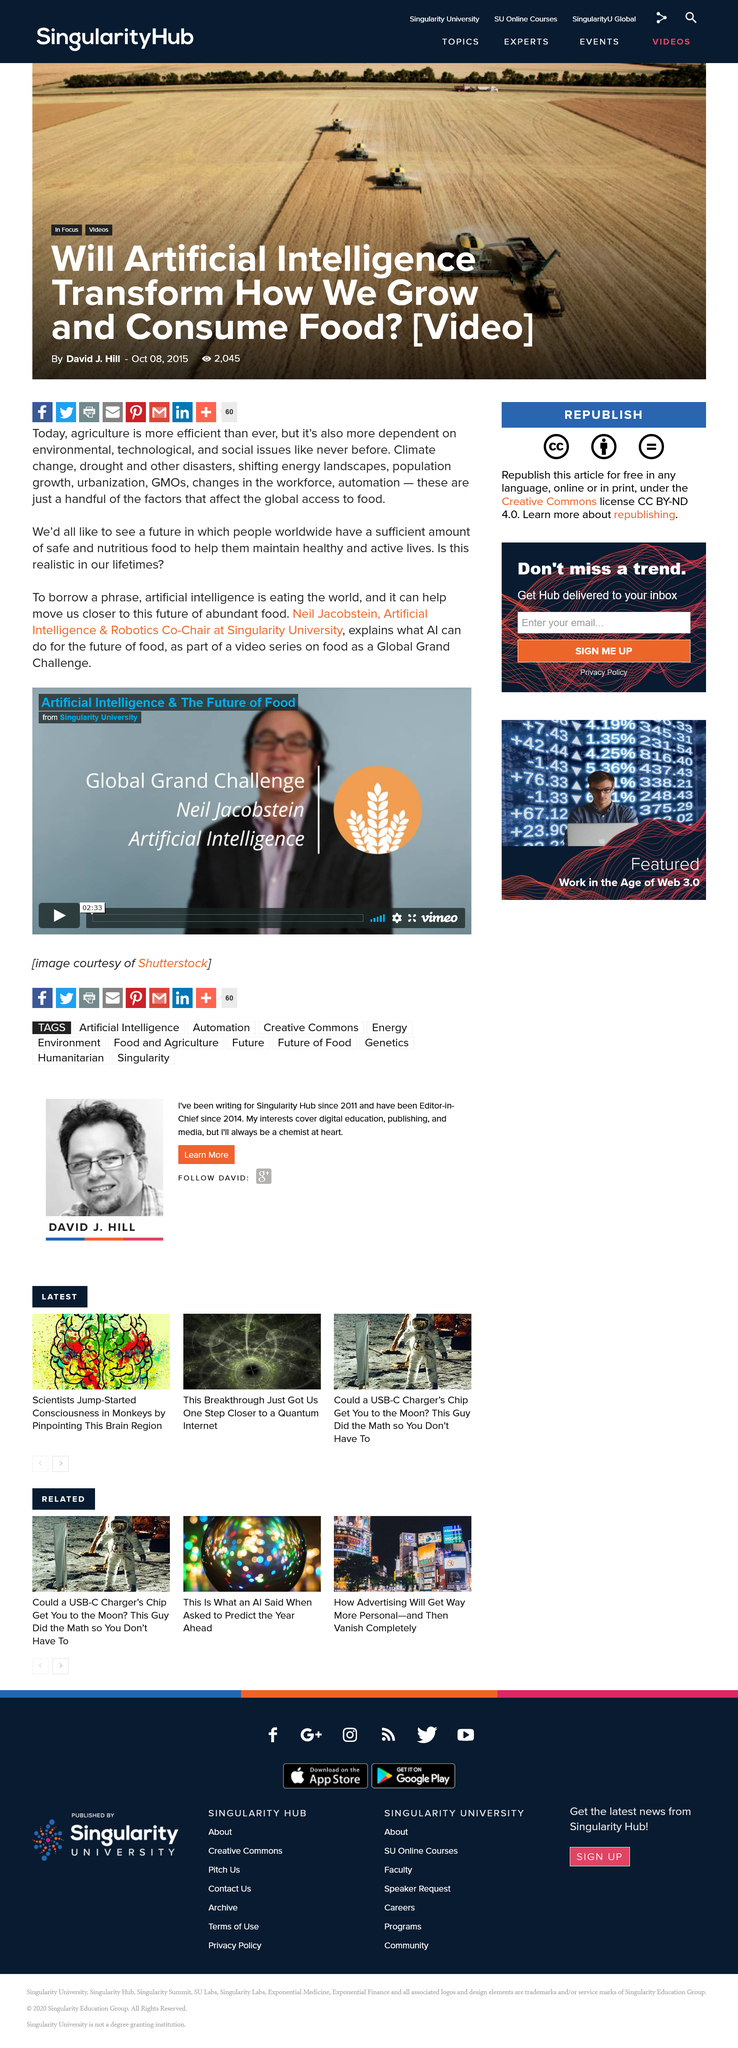Mention a couple of crucial points in this snapshot. Artificial intelligence can move us closer to the future we'd all like to see. Neil Jacobstein explains how AI can bring about significant changes in the future of food, making it more efficient and sustainable. It is known that Neil Jacobson holds the position of Artificial Intelligence & Robotics Co-Chair at Singularity University. 